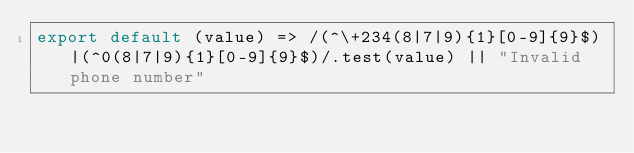<code> <loc_0><loc_0><loc_500><loc_500><_JavaScript_>export default (value) => /(^\+234(8|7|9){1}[0-9]{9}$)|(^0(8|7|9){1}[0-9]{9}$)/.test(value) || "Invalid phone number"</code> 